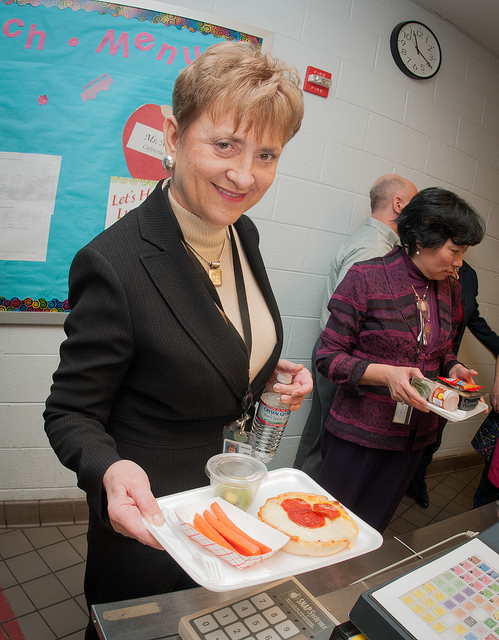What type of food does the man have? In the image, there is a woman carrying the tray, not a man. She has healthy food options including a piece of pizza, crisp carrot sticks, and a side of fruit. 